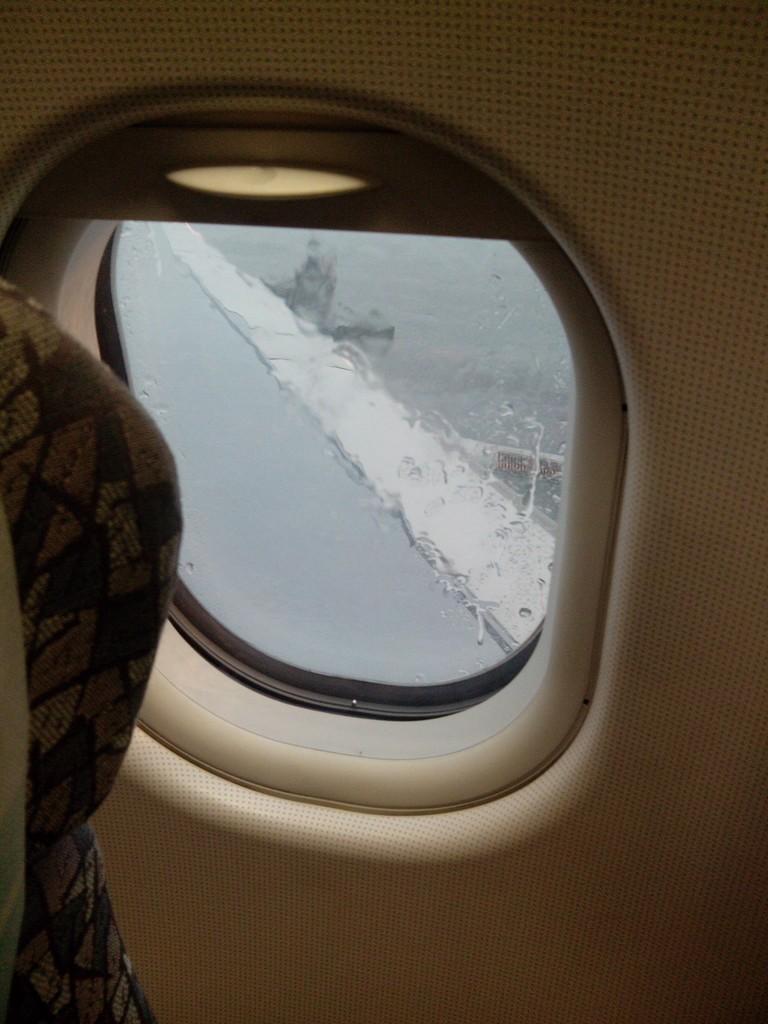In one or two sentences, can you explain what this image depicts? In this image we can see a seat and a window of a vehicle. 